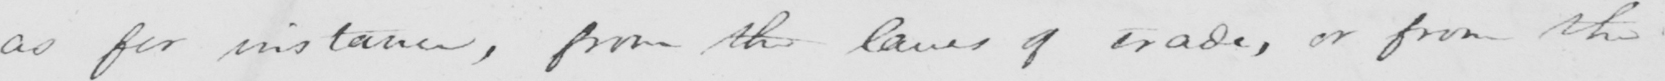What does this handwritten line say? as for instance , from the laws of trade , or from the 